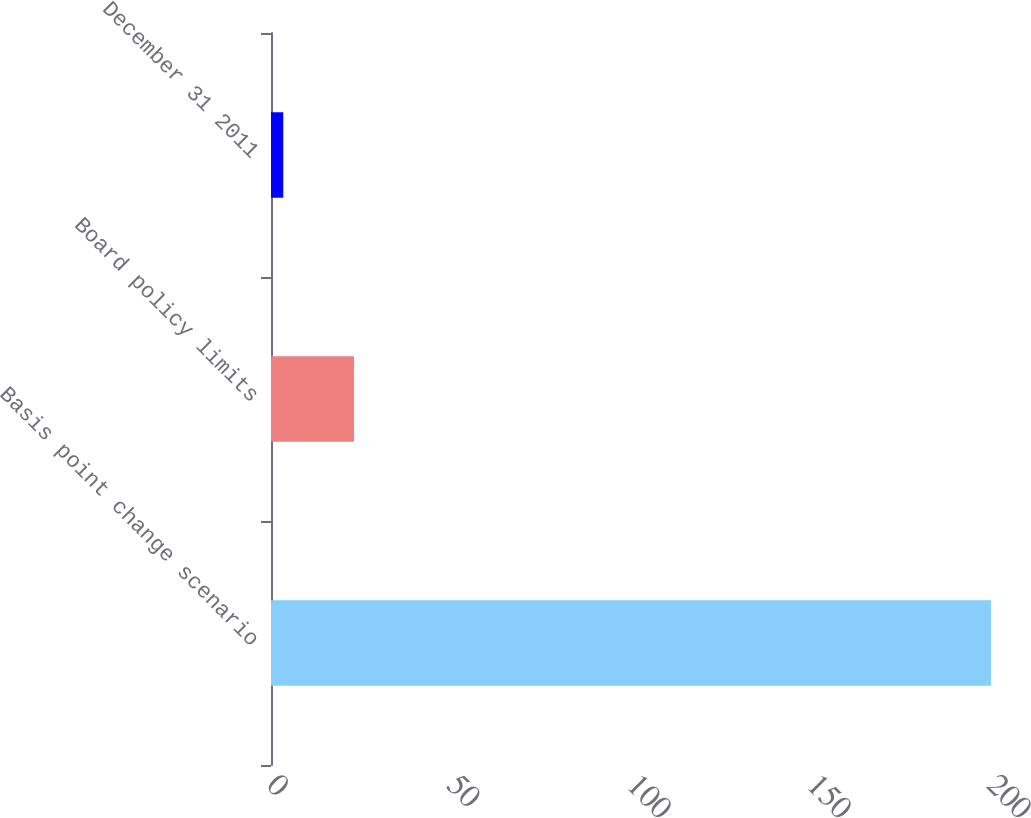Convert chart to OTSL. <chart><loc_0><loc_0><loc_500><loc_500><bar_chart><fcel>Basis point change scenario<fcel>Board policy limits<fcel>December 31 2011<nl><fcel>200<fcel>23.06<fcel>3.4<nl></chart> 